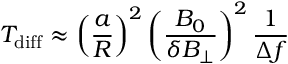Convert formula to latex. <formula><loc_0><loc_0><loc_500><loc_500>T _ { d i f f } \approx \left ( \frac { a } { R } \right ) ^ { 2 } \left ( \frac { B _ { 0 } } { \delta B _ { \perp } } \right ) ^ { 2 } \frac { 1 } { \Delta f }</formula> 